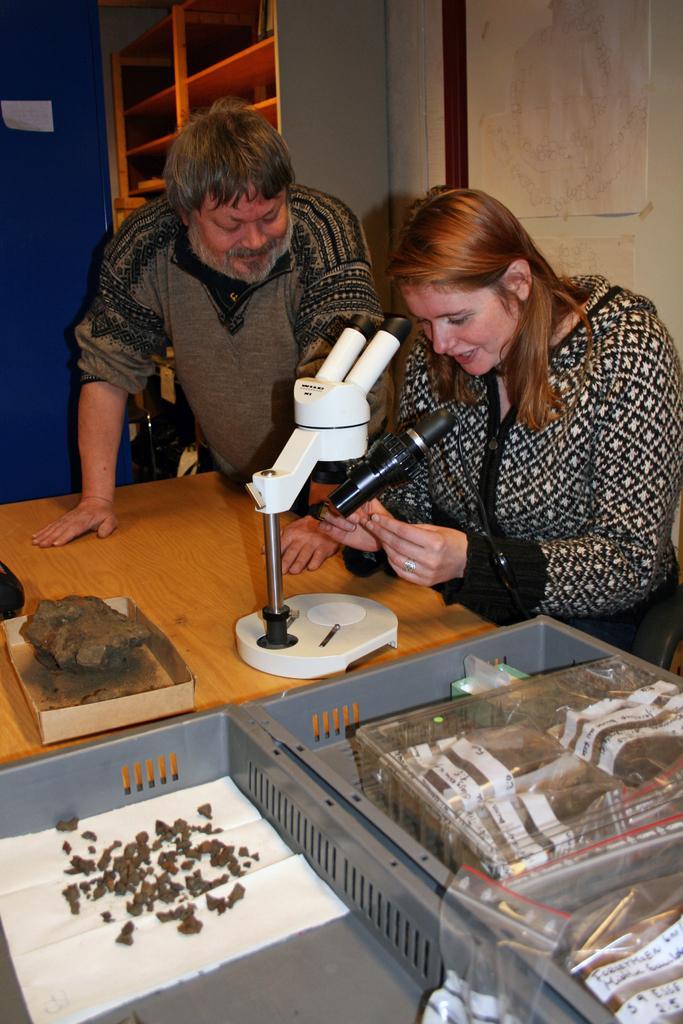Please provide a concise description of this image. This picture is inside the room. There is a person sitting and holding the device, there is an other person standing behind the table. There is a device, stone, paper, covers on the table. At the back there is a cupboard and there is a chart on the wall. 